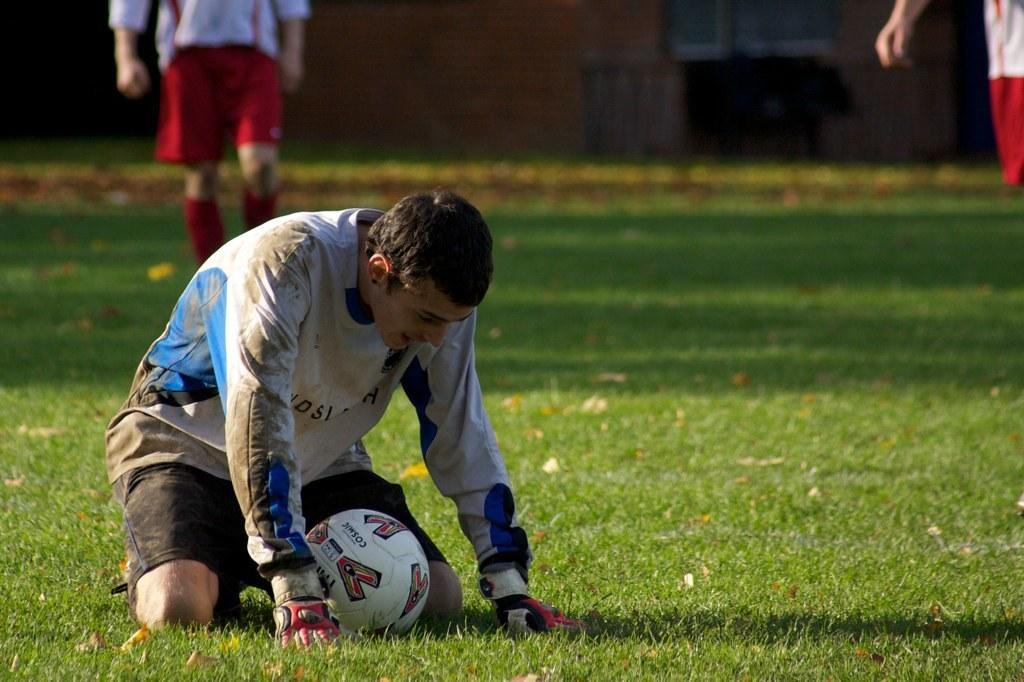Who or what can be seen in the image? There are people in the image. What object is present in the image along with the people? There is a ball in the image. What type of surface can be seen in the image? There is grass in the image. What part of the ball is visible in the image? There is no specific part of the ball mentioned in the image, only that a ball is present. 